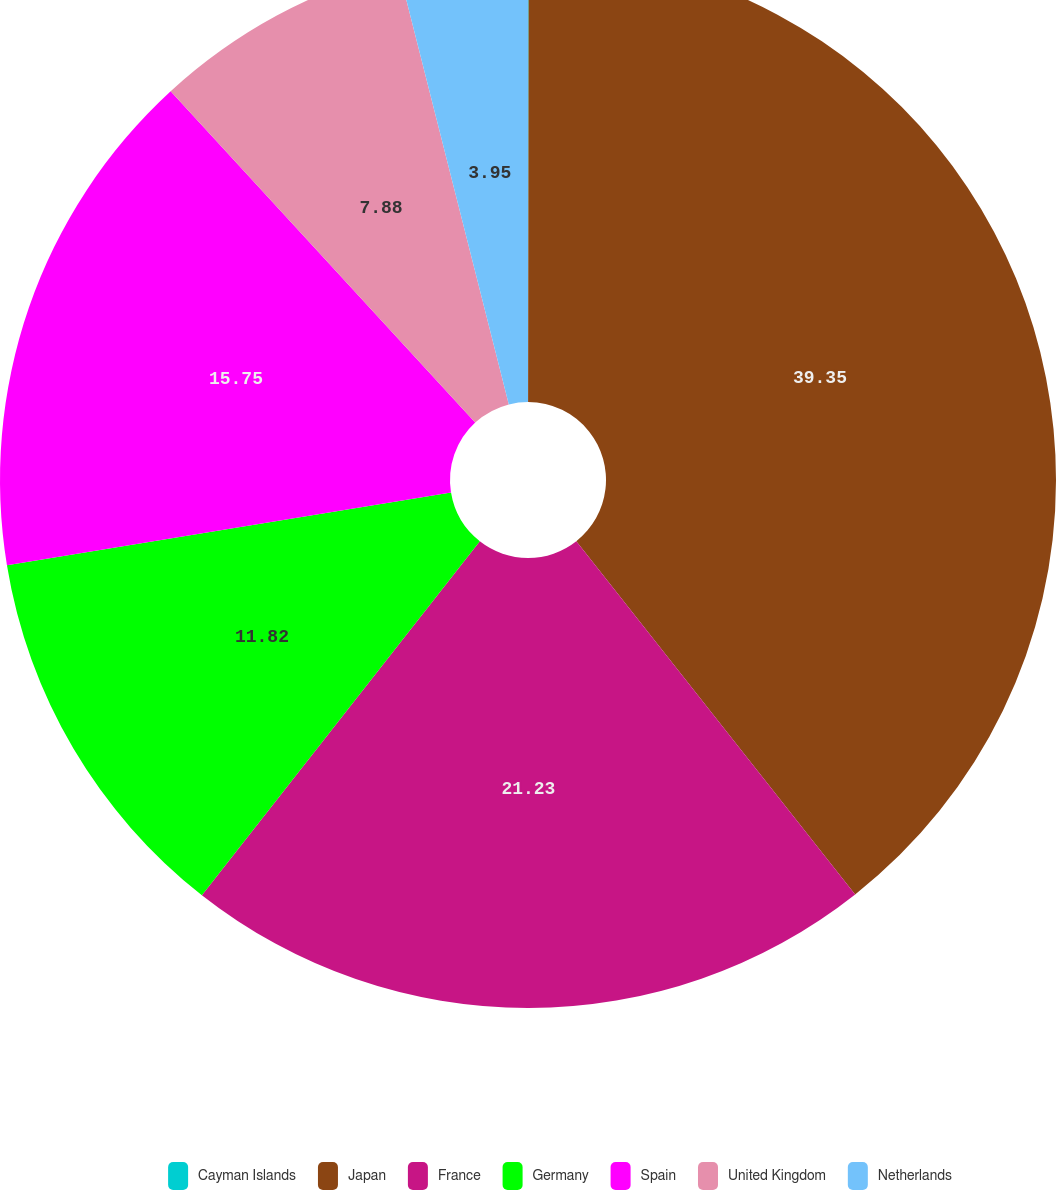Convert chart. <chart><loc_0><loc_0><loc_500><loc_500><pie_chart><fcel>Cayman Islands<fcel>Japan<fcel>France<fcel>Germany<fcel>Spain<fcel>United Kingdom<fcel>Netherlands<nl><fcel>0.02%<fcel>39.34%<fcel>21.23%<fcel>11.82%<fcel>15.75%<fcel>7.88%<fcel>3.95%<nl></chart> 